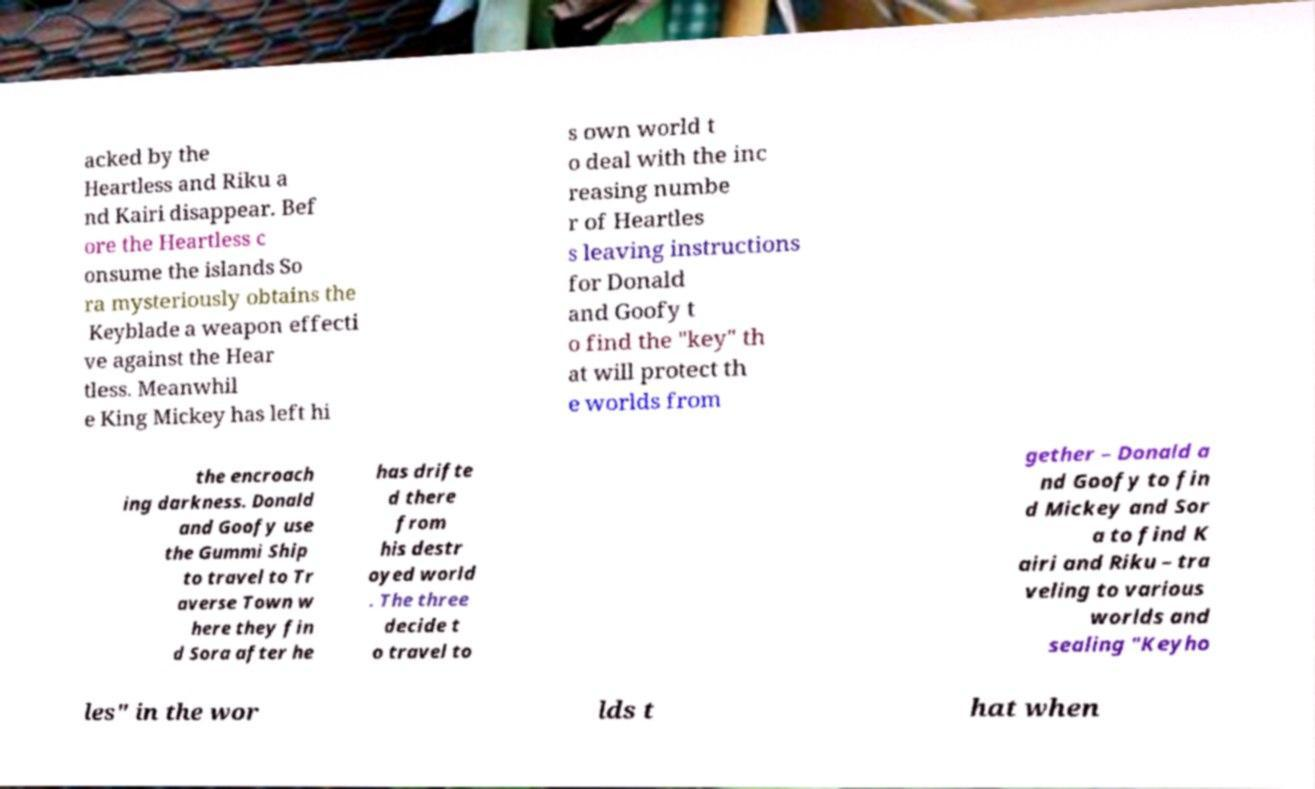Could you extract and type out the text from this image? acked by the Heartless and Riku a nd Kairi disappear. Bef ore the Heartless c onsume the islands So ra mysteriously obtains the Keyblade a weapon effecti ve against the Hear tless. Meanwhil e King Mickey has left hi s own world t o deal with the inc reasing numbe r of Heartles s leaving instructions for Donald and Goofy t o find the "key" th at will protect th e worlds from the encroach ing darkness. Donald and Goofy use the Gummi Ship to travel to Tr averse Town w here they fin d Sora after he has drifte d there from his destr oyed world . The three decide t o travel to gether – Donald a nd Goofy to fin d Mickey and Sor a to find K airi and Riku – tra veling to various worlds and sealing "Keyho les" in the wor lds t hat when 